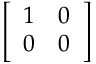Convert formula to latex. <formula><loc_0><loc_0><loc_500><loc_500>\left [ \begin{array} { l l } { 1 } & { 0 } \\ { 0 } & { 0 } \end{array} \right ]</formula> 